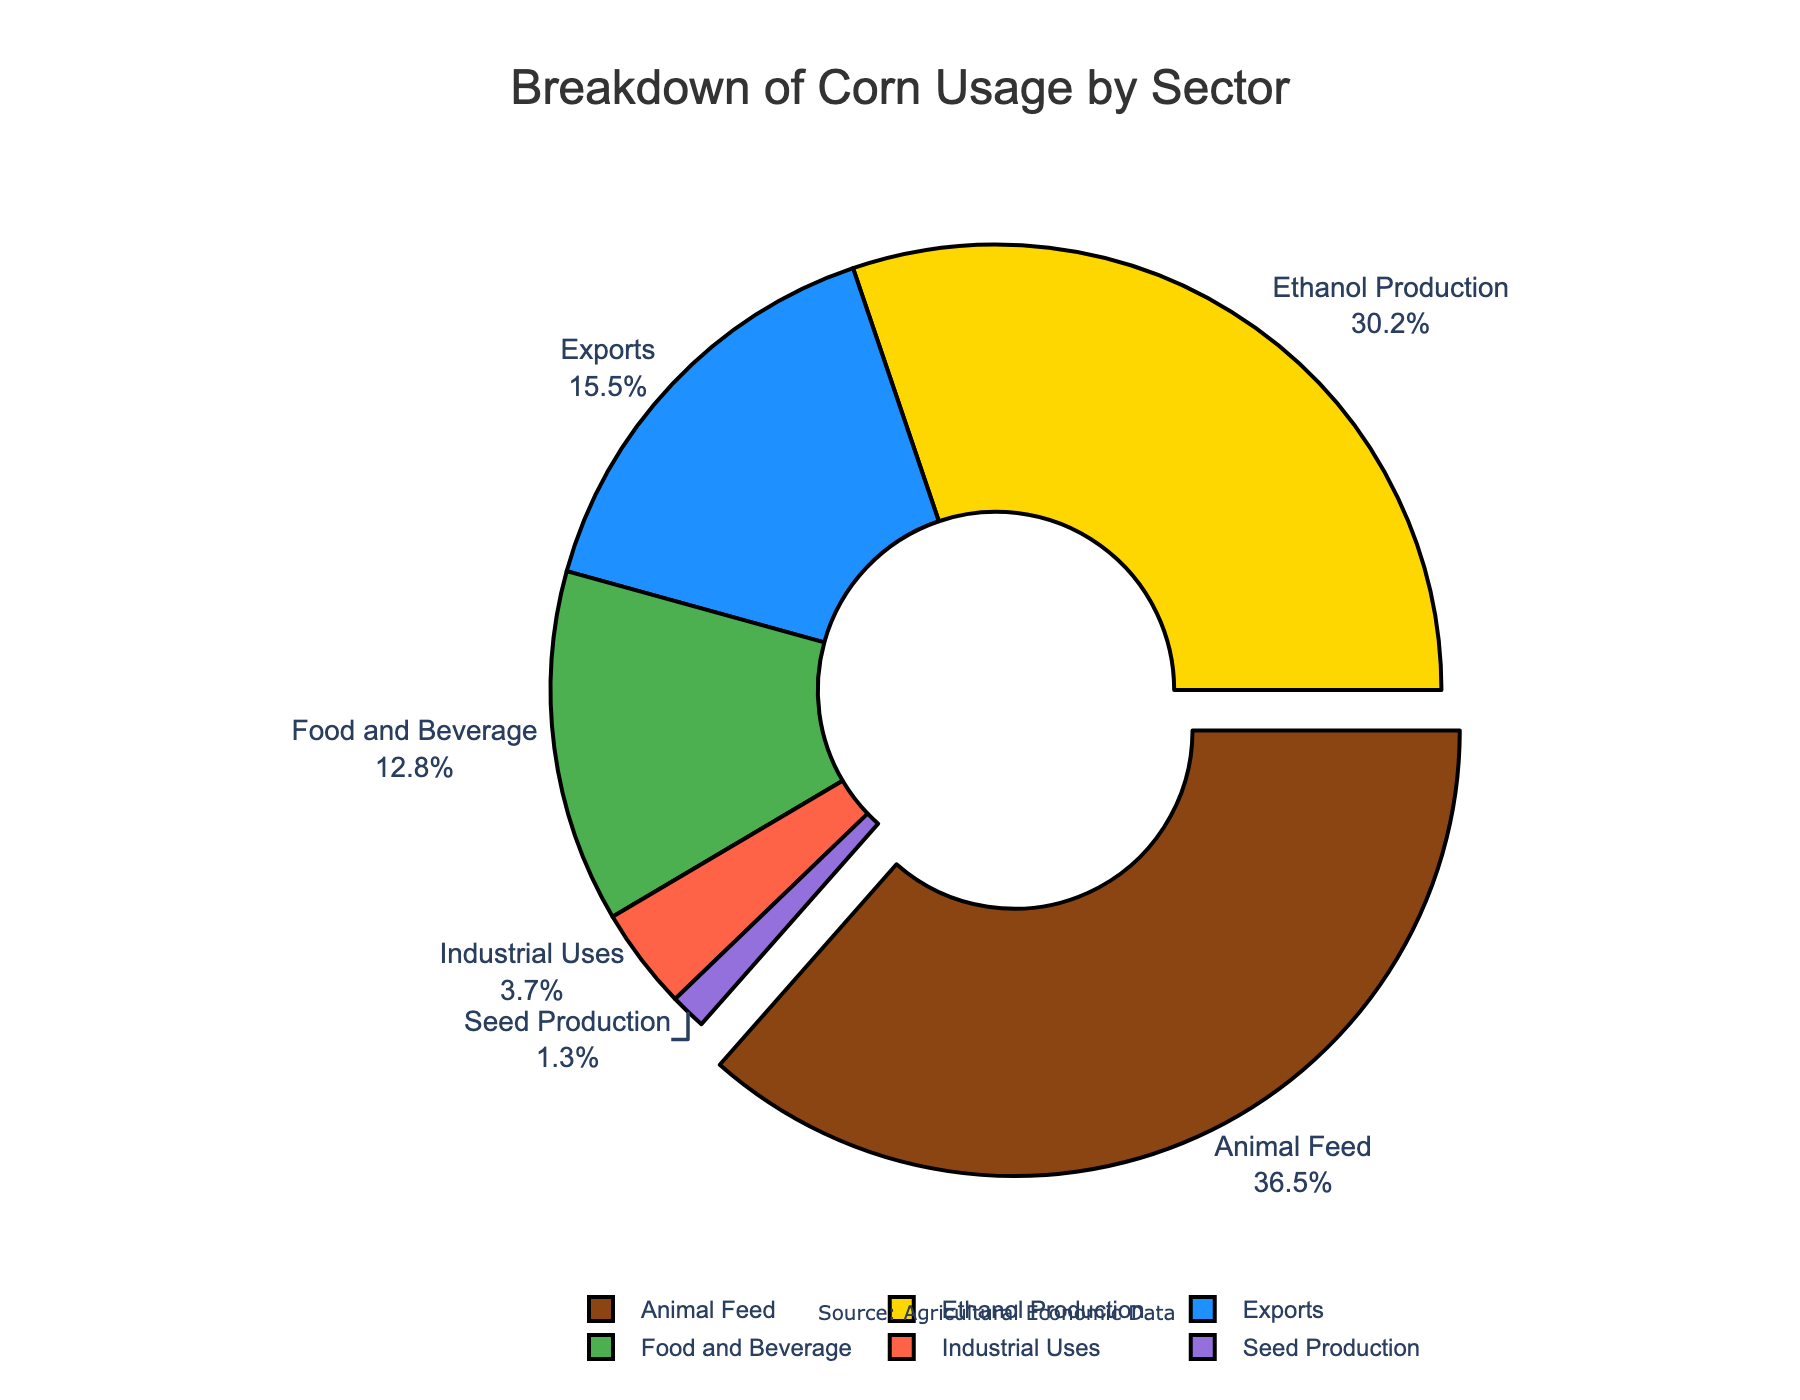Which sector has the highest usage percentage? The sector with the highest usage percentage will have the largest segment in the pie chart, and it will also be labeled with both the sector name and its percentage.
Answer: Animal Feed Which sector has the lowest usage percentage? The sector with the lowest usage percentage will have the smallest segment in the pie chart, and it will also be labeled with both the sector name and its percentage.
Answer: Seed Production What is the combined percentage of corn used for "Animal Feed" and "Ethanol Production"? Add the percentages of "Animal Feed" and "Ethanol Production" together: 36.5% + 30.2%.
Answer: 66.7% Which sector uses less corn, "Exports" or "Industrial Uses"? Find the respective percentages for these sectors on the pie chart and compare them. Exports have 15.5% and Industrial Uses have 3.7%; thus, Industrial Uses is less.
Answer: Industrial Uses How many sectors use less than 10% of the total corn usage? Identify sectors from the pie chart where the percentage is below 10% and count them. "Industrial Uses" (3.7%) and "Seed Production" (1.3%) are the only ones.
Answer: 2 What percentage of the total corn usage is accounted for by the "Food and Beverage" and "Exports" sectors? Add the percentages of "Food and Beverage" (12.8%) and "Exports" (15.5%).
Answer: 28.3% By how much percentage is the "Animal Feed" sector larger than the "Food and Beverage" sector? Subtract the percentage of the "Food and Beverage" sector from the "Animal Feed" sector: 36.5% - 12.8%.
Answer: 23.7% What percentage of corn is used for non-food purposes (excluding "Food and Beverage" and "Seed Production")? Sum the percentages of all non-food sectors: "Animal Feed" (36.5%), "Ethanol Production" (30.2%), "Exports" (15.5%), and "Industrial Uses" (3.7%).
Answer: 85.9% Is the percentage of corn used for "Ethanol Production" more than double the percentage used for "Seed Production"? Compare if the percentage for "Ethanol Production" (30.2%) is more than two times the percentage for "Seed Production" (1.3%) by calculating 30.2 / 1.3.
Answer: Yes Which sector's slice of the pie chart is colored in green? Identify the sector associated with the green color by looking at the visual attributes of the pie chart segments.
Answer: Food and Beverage 